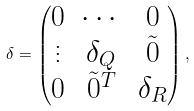Convert formula to latex. <formula><loc_0><loc_0><loc_500><loc_500>\delta = \begin{pmatrix} 0 & \cdots & 0 \\ \vdots & \delta _ { Q } & \tilde { 0 } \\ 0 & \tilde { 0 } ^ { T } & \delta _ { R } \\ \end{pmatrix} ,</formula> 